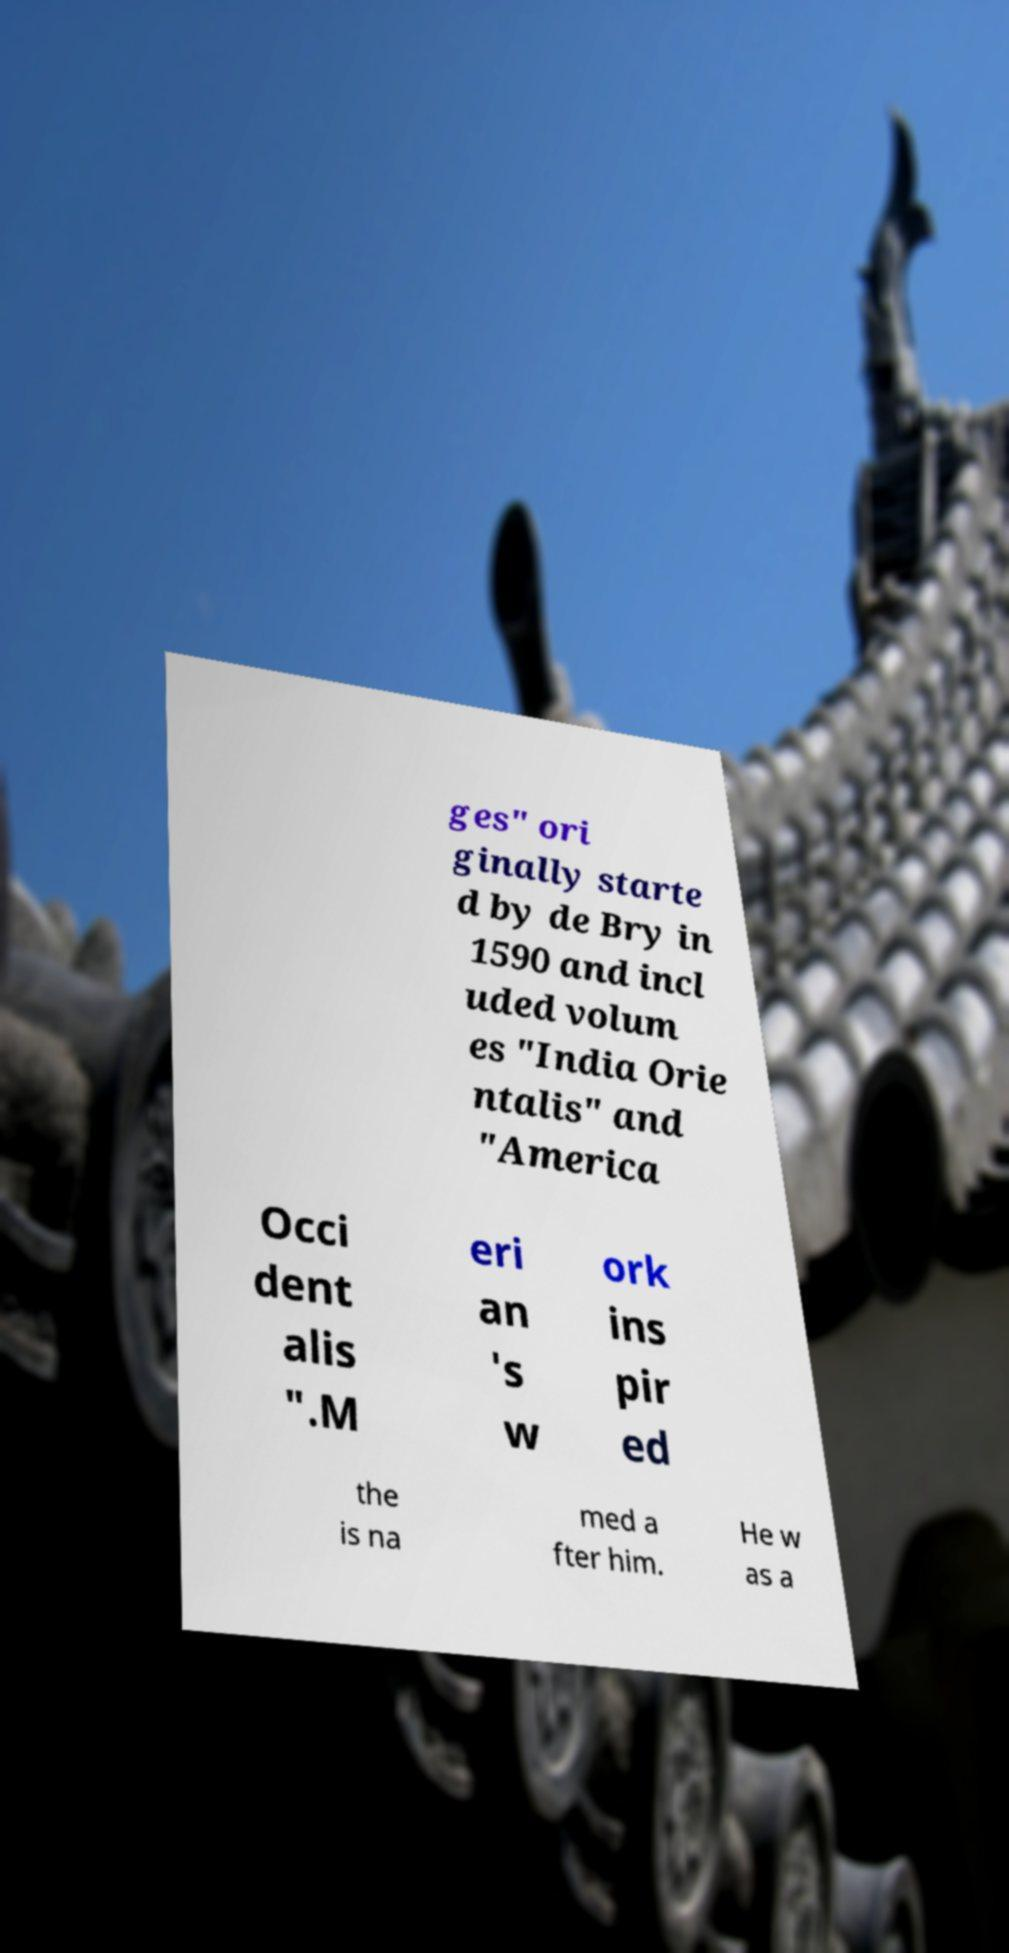Can you read and provide the text displayed in the image?This photo seems to have some interesting text. Can you extract and type it out for me? ges" ori ginally starte d by de Bry in 1590 and incl uded volum es "India Orie ntalis" and "America Occi dent alis ".M eri an 's w ork ins pir ed the is na med a fter him. He w as a 